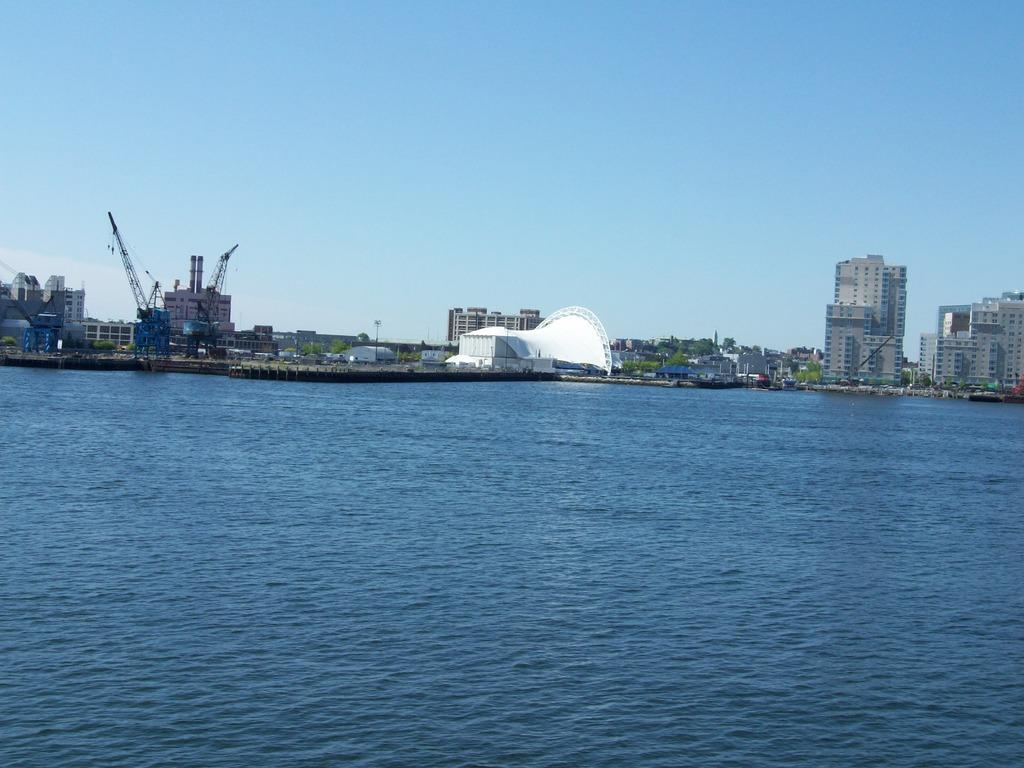What is the main feature in the middle of the image? There is a lake in the middle of the image. What can be seen in the background of the image? There are buildings in the background of the image. What is visible at the top of the image? The sky is visible at the top of the image. What type of machinery is present on the land on the left side of the image? There are cranes on the land on the left side of the image. What type of quilt is being used to cover the lake in the image? There is no quilt present in the image; it features a lake with surrounding land and buildings. Can you see any flesh in the image? There is no flesh visible in the image; it primarily consists of a lake, buildings, sky, and cranes. 